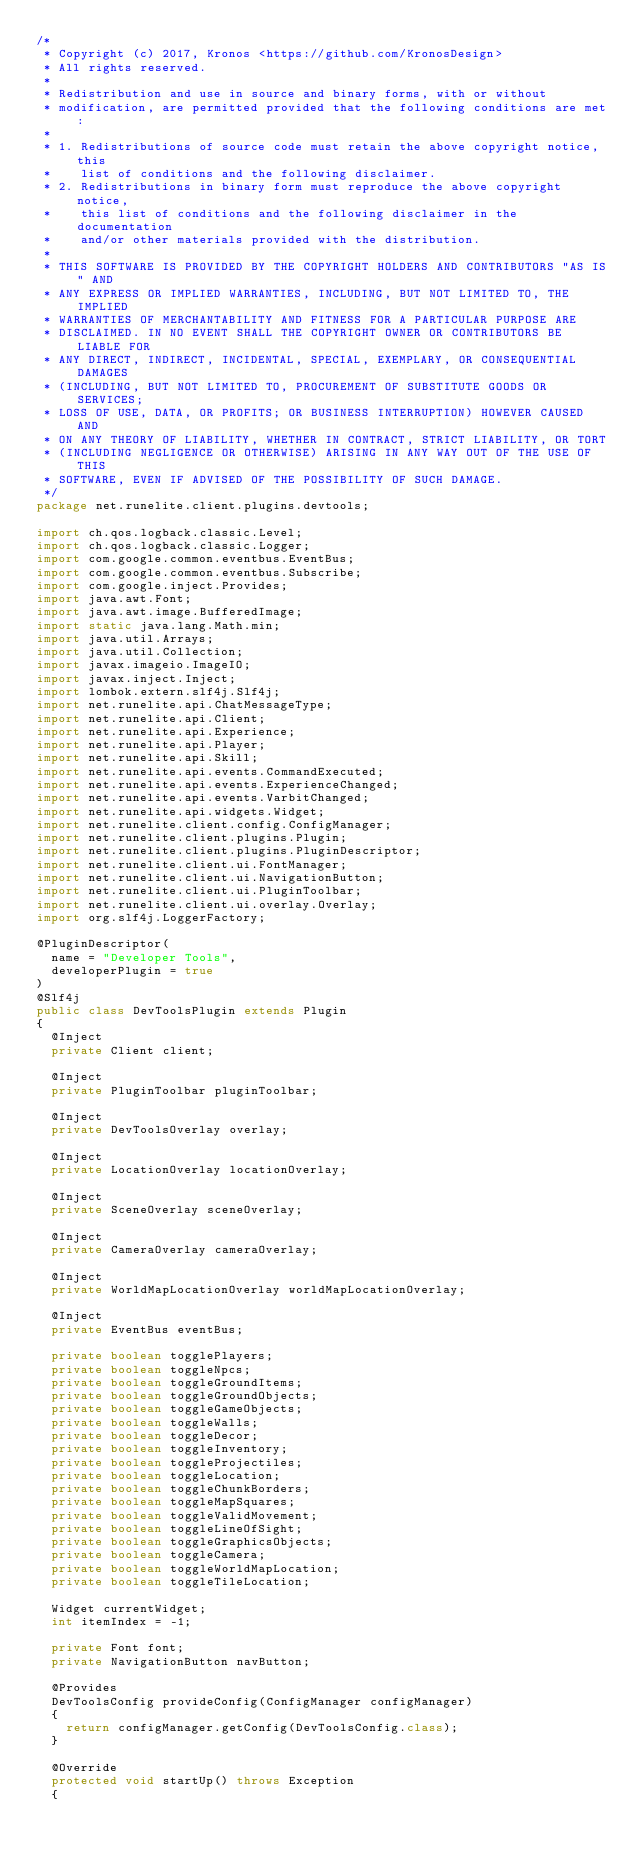<code> <loc_0><loc_0><loc_500><loc_500><_Java_>/*
 * Copyright (c) 2017, Kronos <https://github.com/KronosDesign>
 * All rights reserved.
 *
 * Redistribution and use in source and binary forms, with or without
 * modification, are permitted provided that the following conditions are met:
 *
 * 1. Redistributions of source code must retain the above copyright notice, this
 *    list of conditions and the following disclaimer.
 * 2. Redistributions in binary form must reproduce the above copyright notice,
 *    this list of conditions and the following disclaimer in the documentation
 *    and/or other materials provided with the distribution.
 *
 * THIS SOFTWARE IS PROVIDED BY THE COPYRIGHT HOLDERS AND CONTRIBUTORS "AS IS" AND
 * ANY EXPRESS OR IMPLIED WARRANTIES, INCLUDING, BUT NOT LIMITED TO, THE IMPLIED
 * WARRANTIES OF MERCHANTABILITY AND FITNESS FOR A PARTICULAR PURPOSE ARE
 * DISCLAIMED. IN NO EVENT SHALL THE COPYRIGHT OWNER OR CONTRIBUTORS BE LIABLE FOR
 * ANY DIRECT, INDIRECT, INCIDENTAL, SPECIAL, EXEMPLARY, OR CONSEQUENTIAL DAMAGES
 * (INCLUDING, BUT NOT LIMITED TO, PROCUREMENT OF SUBSTITUTE GOODS OR SERVICES;
 * LOSS OF USE, DATA, OR PROFITS; OR BUSINESS INTERRUPTION) HOWEVER CAUSED AND
 * ON ANY THEORY OF LIABILITY, WHETHER IN CONTRACT, STRICT LIABILITY, OR TORT
 * (INCLUDING NEGLIGENCE OR OTHERWISE) ARISING IN ANY WAY OUT OF THE USE OF THIS
 * SOFTWARE, EVEN IF ADVISED OF THE POSSIBILITY OF SUCH DAMAGE.
 */
package net.runelite.client.plugins.devtools;

import ch.qos.logback.classic.Level;
import ch.qos.logback.classic.Logger;
import com.google.common.eventbus.EventBus;
import com.google.common.eventbus.Subscribe;
import com.google.inject.Provides;
import java.awt.Font;
import java.awt.image.BufferedImage;
import static java.lang.Math.min;
import java.util.Arrays;
import java.util.Collection;
import javax.imageio.ImageIO;
import javax.inject.Inject;
import lombok.extern.slf4j.Slf4j;
import net.runelite.api.ChatMessageType;
import net.runelite.api.Client;
import net.runelite.api.Experience;
import net.runelite.api.Player;
import net.runelite.api.Skill;
import net.runelite.api.events.CommandExecuted;
import net.runelite.api.events.ExperienceChanged;
import net.runelite.api.events.VarbitChanged;
import net.runelite.api.widgets.Widget;
import net.runelite.client.config.ConfigManager;
import net.runelite.client.plugins.Plugin;
import net.runelite.client.plugins.PluginDescriptor;
import net.runelite.client.ui.FontManager;
import net.runelite.client.ui.NavigationButton;
import net.runelite.client.ui.PluginToolbar;
import net.runelite.client.ui.overlay.Overlay;
import org.slf4j.LoggerFactory;

@PluginDescriptor(
	name = "Developer Tools",
	developerPlugin = true
)
@Slf4j
public class DevToolsPlugin extends Plugin
{
	@Inject
	private Client client;

	@Inject
	private PluginToolbar pluginToolbar;

	@Inject
	private DevToolsOverlay overlay;

	@Inject
	private LocationOverlay locationOverlay;

	@Inject
	private SceneOverlay sceneOverlay;

	@Inject
	private CameraOverlay cameraOverlay;

	@Inject
	private WorldMapLocationOverlay worldMapLocationOverlay;

	@Inject
	private EventBus eventBus;

	private boolean togglePlayers;
	private boolean toggleNpcs;
	private boolean toggleGroundItems;
	private boolean toggleGroundObjects;
	private boolean toggleGameObjects;
	private boolean toggleWalls;
	private boolean toggleDecor;
	private boolean toggleInventory;
	private boolean toggleProjectiles;
	private boolean toggleLocation;
	private boolean toggleChunkBorders;
	private boolean toggleMapSquares;
	private boolean toggleValidMovement;
	private boolean toggleLineOfSight;
	private boolean toggleGraphicsObjects;
	private boolean toggleCamera;
	private boolean toggleWorldMapLocation;
	private boolean toggleTileLocation;

	Widget currentWidget;
	int itemIndex = -1;

	private Font font;
	private NavigationButton navButton;

	@Provides
	DevToolsConfig provideConfig(ConfigManager configManager)
	{
		return configManager.getConfig(DevToolsConfig.class);
	}

	@Override
	protected void startUp() throws Exception
	{</code> 